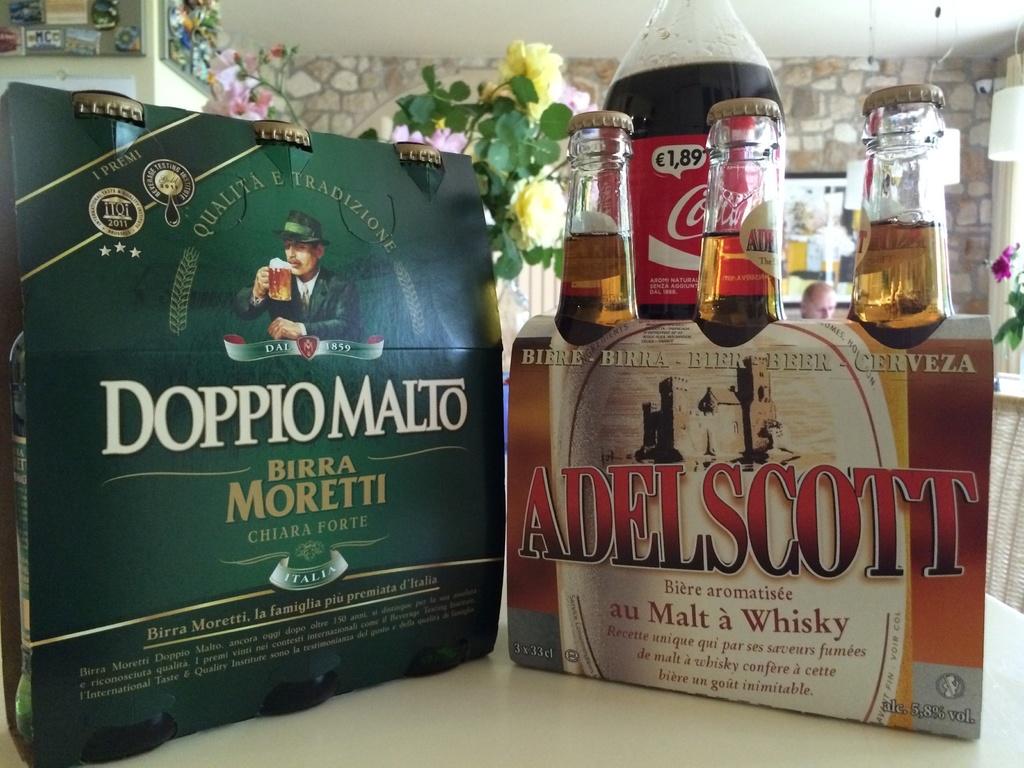What is the name of the whiskey?
Your answer should be very brief. Adelscott. How much is the coke?
Your response must be concise. 1.89. 